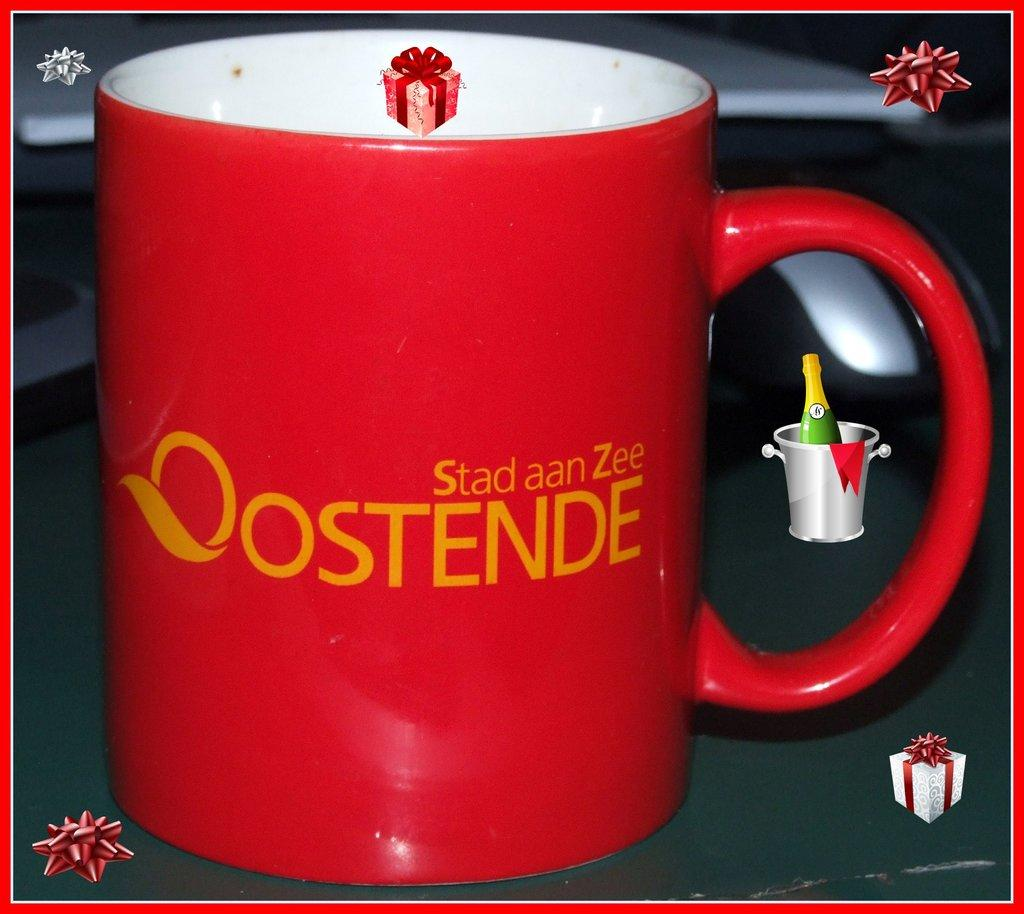<image>
Create a compact narrative representing the image presented. An Oostende mug is surrounded by celebratory clip art. 